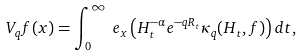Convert formula to latex. <formula><loc_0><loc_0><loc_500><loc_500>V _ { q } f ( x ) & = \int ^ { \infty } _ { 0 } \ e _ { x } \left ( H ^ { - \alpha } _ { t } e ^ { - q R _ { t } } \kappa _ { q } ( H _ { t } , f ) \right ) d t ,</formula> 